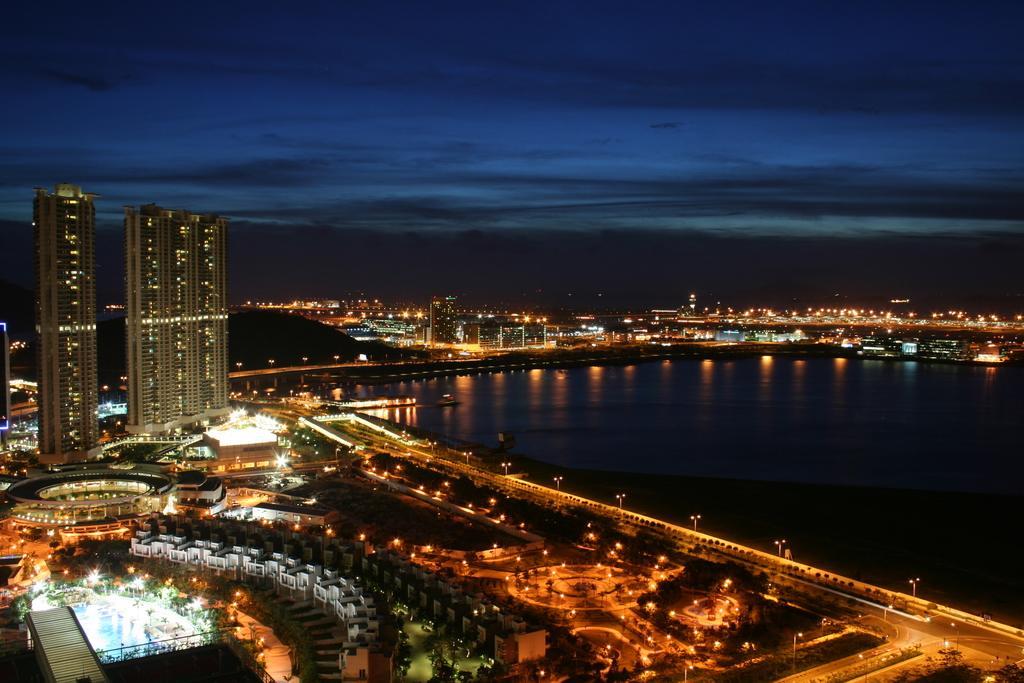In one or two sentences, can you explain what this image depicts? In this image we can see a few buildings, there are some trees, poles, lights and water, in the background, we can see the sky with clouds. 